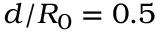Convert formula to latex. <formula><loc_0><loc_0><loc_500><loc_500>d / R _ { 0 } = 0 . 5</formula> 